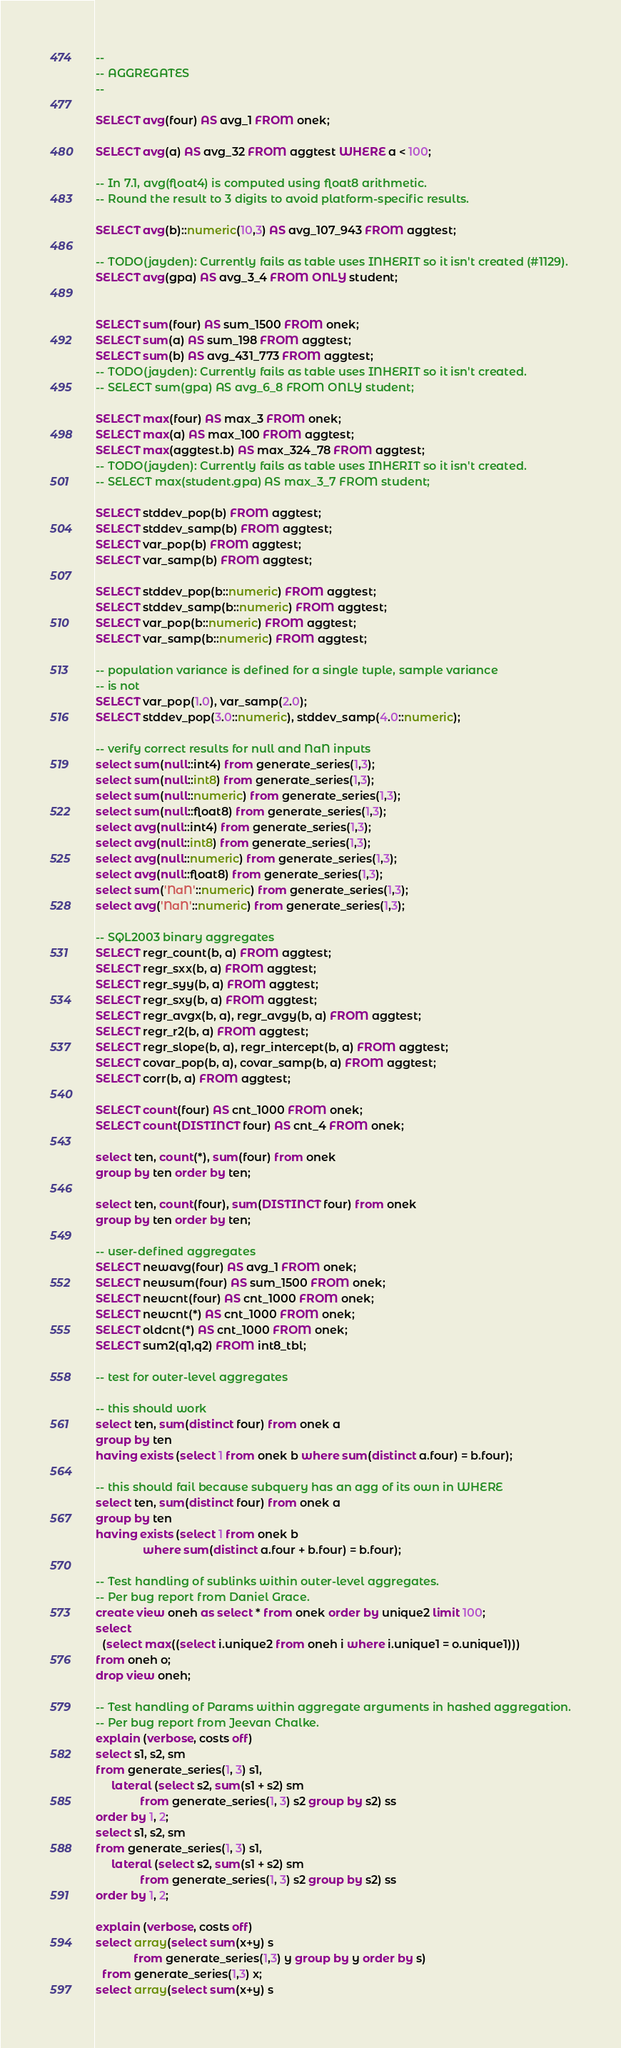Convert code to text. <code><loc_0><loc_0><loc_500><loc_500><_SQL_>--
-- AGGREGATES
--

SELECT avg(four) AS avg_1 FROM onek;

SELECT avg(a) AS avg_32 FROM aggtest WHERE a < 100;

-- In 7.1, avg(float4) is computed using float8 arithmetic.
-- Round the result to 3 digits to avoid platform-specific results.

SELECT avg(b)::numeric(10,3) AS avg_107_943 FROM aggtest;

-- TODO(jayden): Currently fails as table uses INHERIT so it isn't created (#1129).
SELECT avg(gpa) AS avg_3_4 FROM ONLY student;


SELECT sum(four) AS sum_1500 FROM onek;
SELECT sum(a) AS sum_198 FROM aggtest;
SELECT sum(b) AS avg_431_773 FROM aggtest;
-- TODO(jayden): Currently fails as table uses INHERIT so it isn't created.
-- SELECT sum(gpa) AS avg_6_8 FROM ONLY student;

SELECT max(four) AS max_3 FROM onek;
SELECT max(a) AS max_100 FROM aggtest;
SELECT max(aggtest.b) AS max_324_78 FROM aggtest;
-- TODO(jayden): Currently fails as table uses INHERIT so it isn't created.
-- SELECT max(student.gpa) AS max_3_7 FROM student;

SELECT stddev_pop(b) FROM aggtest;
SELECT stddev_samp(b) FROM aggtest;
SELECT var_pop(b) FROM aggtest;
SELECT var_samp(b) FROM aggtest;

SELECT stddev_pop(b::numeric) FROM aggtest;
SELECT stddev_samp(b::numeric) FROM aggtest;
SELECT var_pop(b::numeric) FROM aggtest;
SELECT var_samp(b::numeric) FROM aggtest;

-- population variance is defined for a single tuple, sample variance
-- is not
SELECT var_pop(1.0), var_samp(2.0);
SELECT stddev_pop(3.0::numeric), stddev_samp(4.0::numeric);

-- verify correct results for null and NaN inputs
select sum(null::int4) from generate_series(1,3);
select sum(null::int8) from generate_series(1,3);
select sum(null::numeric) from generate_series(1,3);
select sum(null::float8) from generate_series(1,3);
select avg(null::int4) from generate_series(1,3);
select avg(null::int8) from generate_series(1,3);
select avg(null::numeric) from generate_series(1,3);
select avg(null::float8) from generate_series(1,3);
select sum('NaN'::numeric) from generate_series(1,3);
select avg('NaN'::numeric) from generate_series(1,3);

-- SQL2003 binary aggregates
SELECT regr_count(b, a) FROM aggtest;
SELECT regr_sxx(b, a) FROM aggtest;
SELECT regr_syy(b, a) FROM aggtest;
SELECT regr_sxy(b, a) FROM aggtest;
SELECT regr_avgx(b, a), regr_avgy(b, a) FROM aggtest;
SELECT regr_r2(b, a) FROM aggtest;
SELECT regr_slope(b, a), regr_intercept(b, a) FROM aggtest;
SELECT covar_pop(b, a), covar_samp(b, a) FROM aggtest;
SELECT corr(b, a) FROM aggtest;

SELECT count(four) AS cnt_1000 FROM onek;
SELECT count(DISTINCT four) AS cnt_4 FROM onek;

select ten, count(*), sum(four) from onek
group by ten order by ten;

select ten, count(four), sum(DISTINCT four) from onek
group by ten order by ten;

-- user-defined aggregates
SELECT newavg(four) AS avg_1 FROM onek;
SELECT newsum(four) AS sum_1500 FROM onek;
SELECT newcnt(four) AS cnt_1000 FROM onek;
SELECT newcnt(*) AS cnt_1000 FROM onek;
SELECT oldcnt(*) AS cnt_1000 FROM onek;
SELECT sum2(q1,q2) FROM int8_tbl;

-- test for outer-level aggregates

-- this should work
select ten, sum(distinct four) from onek a
group by ten
having exists (select 1 from onek b where sum(distinct a.four) = b.four);

-- this should fail because subquery has an agg of its own in WHERE
select ten, sum(distinct four) from onek a
group by ten
having exists (select 1 from onek b
               where sum(distinct a.four + b.four) = b.four);

-- Test handling of sublinks within outer-level aggregates.
-- Per bug report from Daniel Grace.
create view oneh as select * from onek order by unique2 limit 100;
select
  (select max((select i.unique2 from oneh i where i.unique1 = o.unique1)))
from oneh o;
drop view oneh;

-- Test handling of Params within aggregate arguments in hashed aggregation.
-- Per bug report from Jeevan Chalke.
explain (verbose, costs off)
select s1, s2, sm
from generate_series(1, 3) s1,
     lateral (select s2, sum(s1 + s2) sm
              from generate_series(1, 3) s2 group by s2) ss
order by 1, 2;
select s1, s2, sm
from generate_series(1, 3) s1,
     lateral (select s2, sum(s1 + s2) sm
              from generate_series(1, 3) s2 group by s2) ss
order by 1, 2;

explain (verbose, costs off)
select array(select sum(x+y) s
            from generate_series(1,3) y group by y order by s)
  from generate_series(1,3) x;
select array(select sum(x+y) s</code> 